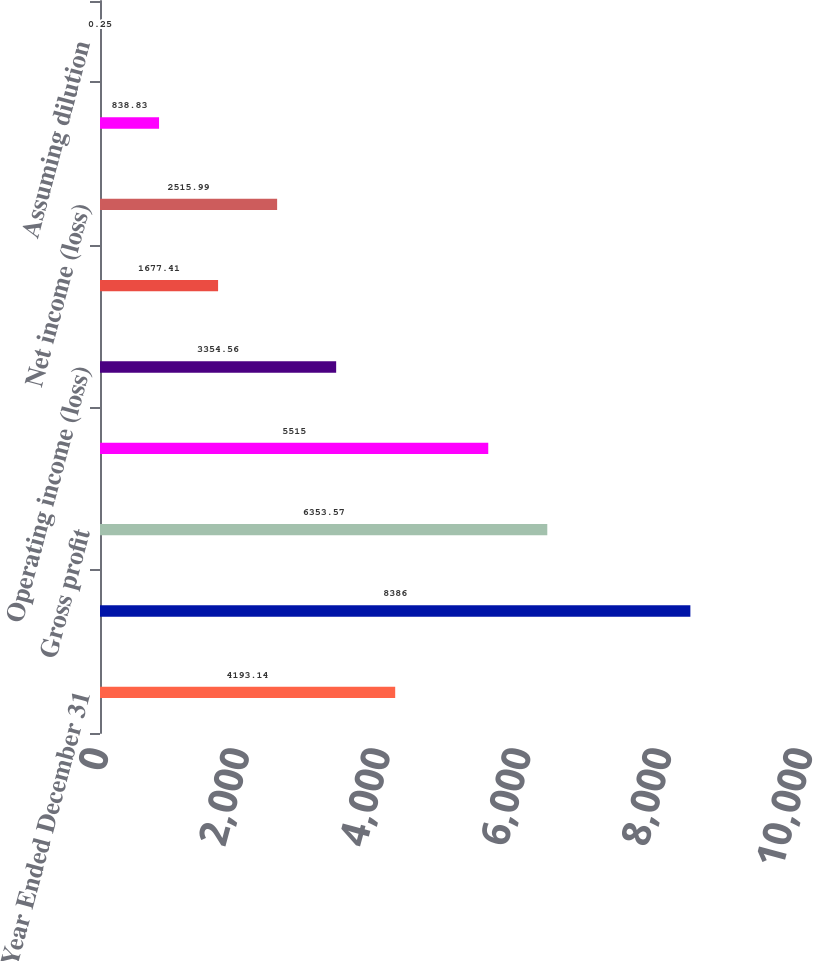Convert chart. <chart><loc_0><loc_0><loc_500><loc_500><bar_chart><fcel>Year Ended December 31<fcel>Net sales<fcel>Gross profit<fcel>Total operating expenses<fcel>Operating income (loss)<fcel>Income (loss) before income<fcel>Net income (loss)<fcel>Basic<fcel>Assuming dilution<nl><fcel>4193.14<fcel>8386<fcel>6353.57<fcel>5515<fcel>3354.56<fcel>1677.41<fcel>2515.99<fcel>838.83<fcel>0.25<nl></chart> 